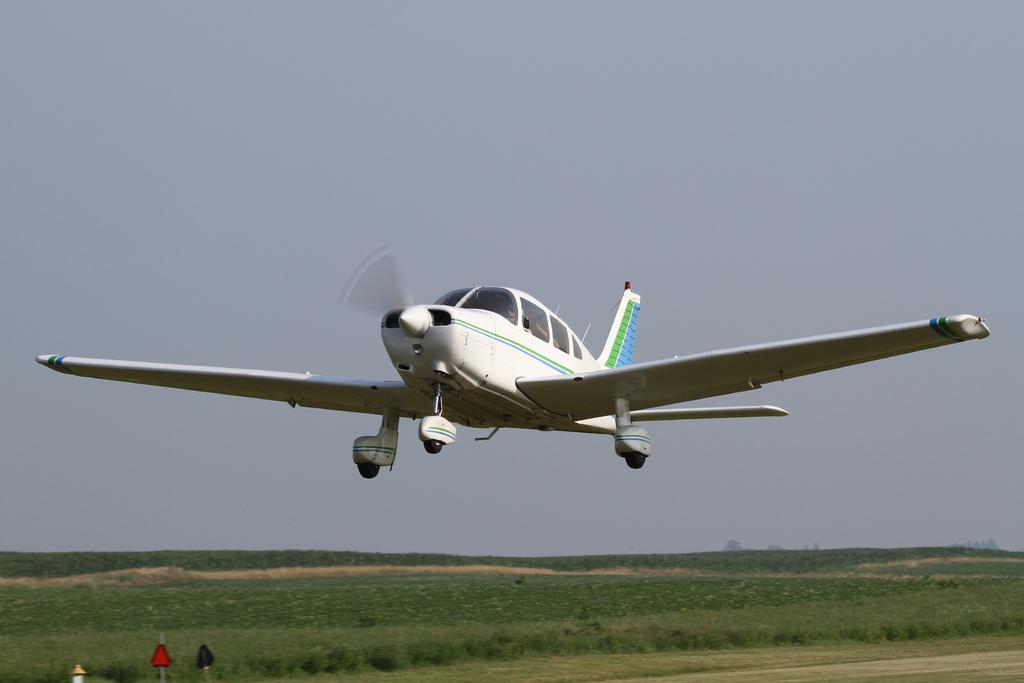What is the main subject in the foreground of the image? There is a plane in the air in the foreground of the image. What type of landscape can be seen at the bottom of the image? There is greenery visible at the bottom of the image. What part of the natural environment is visible at the top of the image? The sky is visible at the top of the image. How many doctors are visible in the image? There are no doctors present in the image. What type of territory is depicted in the image? The image does not depict a specific territory; it simply shows a plane in the air, greenery, and the sky. 